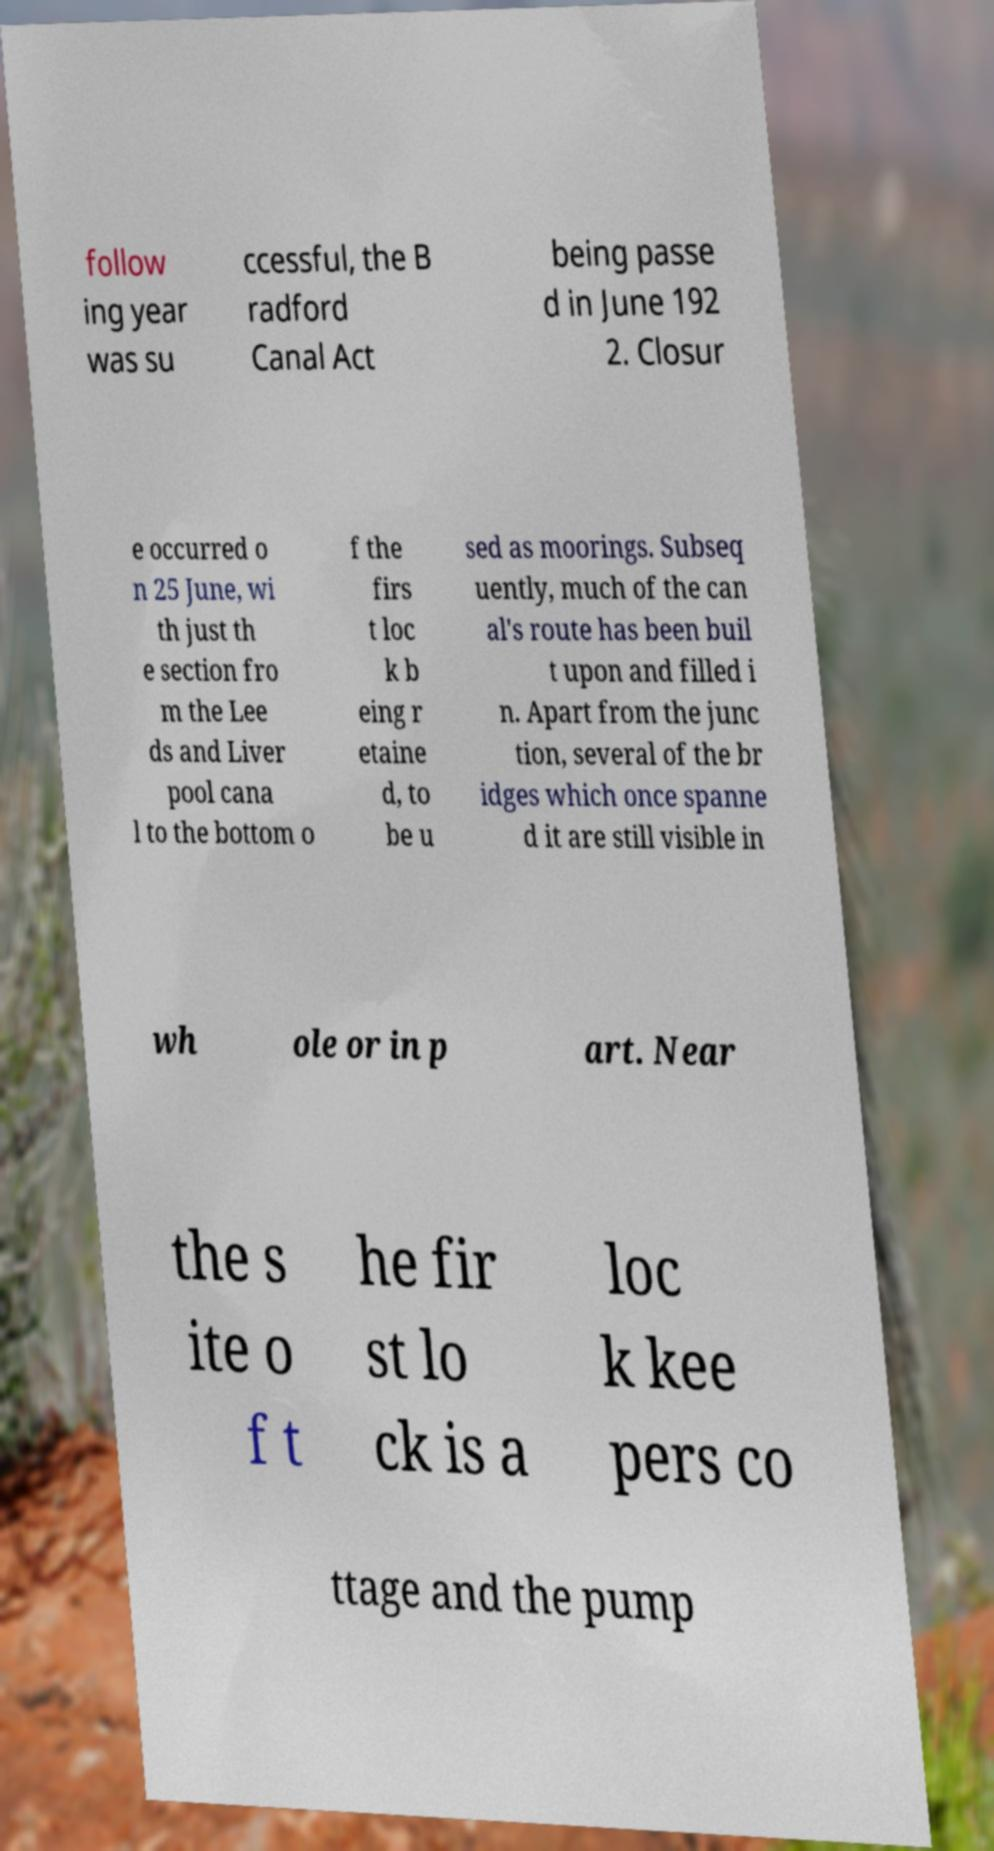I need the written content from this picture converted into text. Can you do that? follow ing year was su ccessful, the B radford Canal Act being passe d in June 192 2. Closur e occurred o n 25 June, wi th just th e section fro m the Lee ds and Liver pool cana l to the bottom o f the firs t loc k b eing r etaine d, to be u sed as moorings. Subseq uently, much of the can al's route has been buil t upon and filled i n. Apart from the junc tion, several of the br idges which once spanne d it are still visible in wh ole or in p art. Near the s ite o f t he fir st lo ck is a loc k kee pers co ttage and the pump 